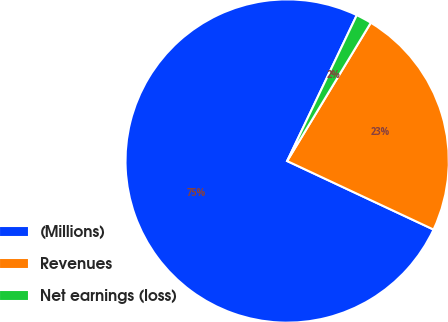<chart> <loc_0><loc_0><loc_500><loc_500><pie_chart><fcel>(Millions)<fcel>Revenues<fcel>Net earnings (loss)<nl><fcel>75.11%<fcel>23.31%<fcel>1.57%<nl></chart> 